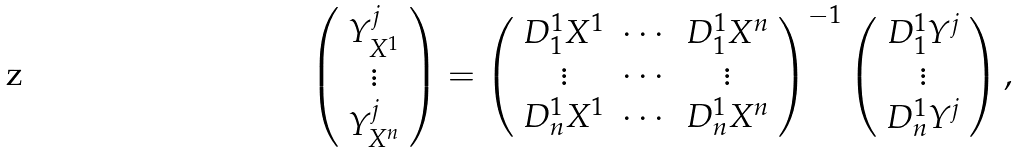<formula> <loc_0><loc_0><loc_500><loc_500>\left ( \begin{array} { c } Y _ { X ^ { 1 } } ^ { j } \\ \vdots \\ Y _ { X ^ { n } } ^ { j } \\ \end{array} \right ) = \left ( \begin{array} { c c c } D _ { 1 } ^ { 1 } X ^ { 1 } & \cdots & D _ { 1 } ^ { 1 } X ^ { n } \\ \vdots & \cdots & \vdots \\ D _ { n } ^ { 1 } X ^ { 1 } & \cdots & D _ { n } ^ { 1 } X ^ { n } \\ \end{array} \right ) ^ { - 1 } \left ( \begin{array} { c } D _ { 1 } ^ { 1 } Y ^ { j } \\ \vdots \\ D _ { n } ^ { 1 } Y ^ { j } \\ \end{array} \right ) ,</formula> 